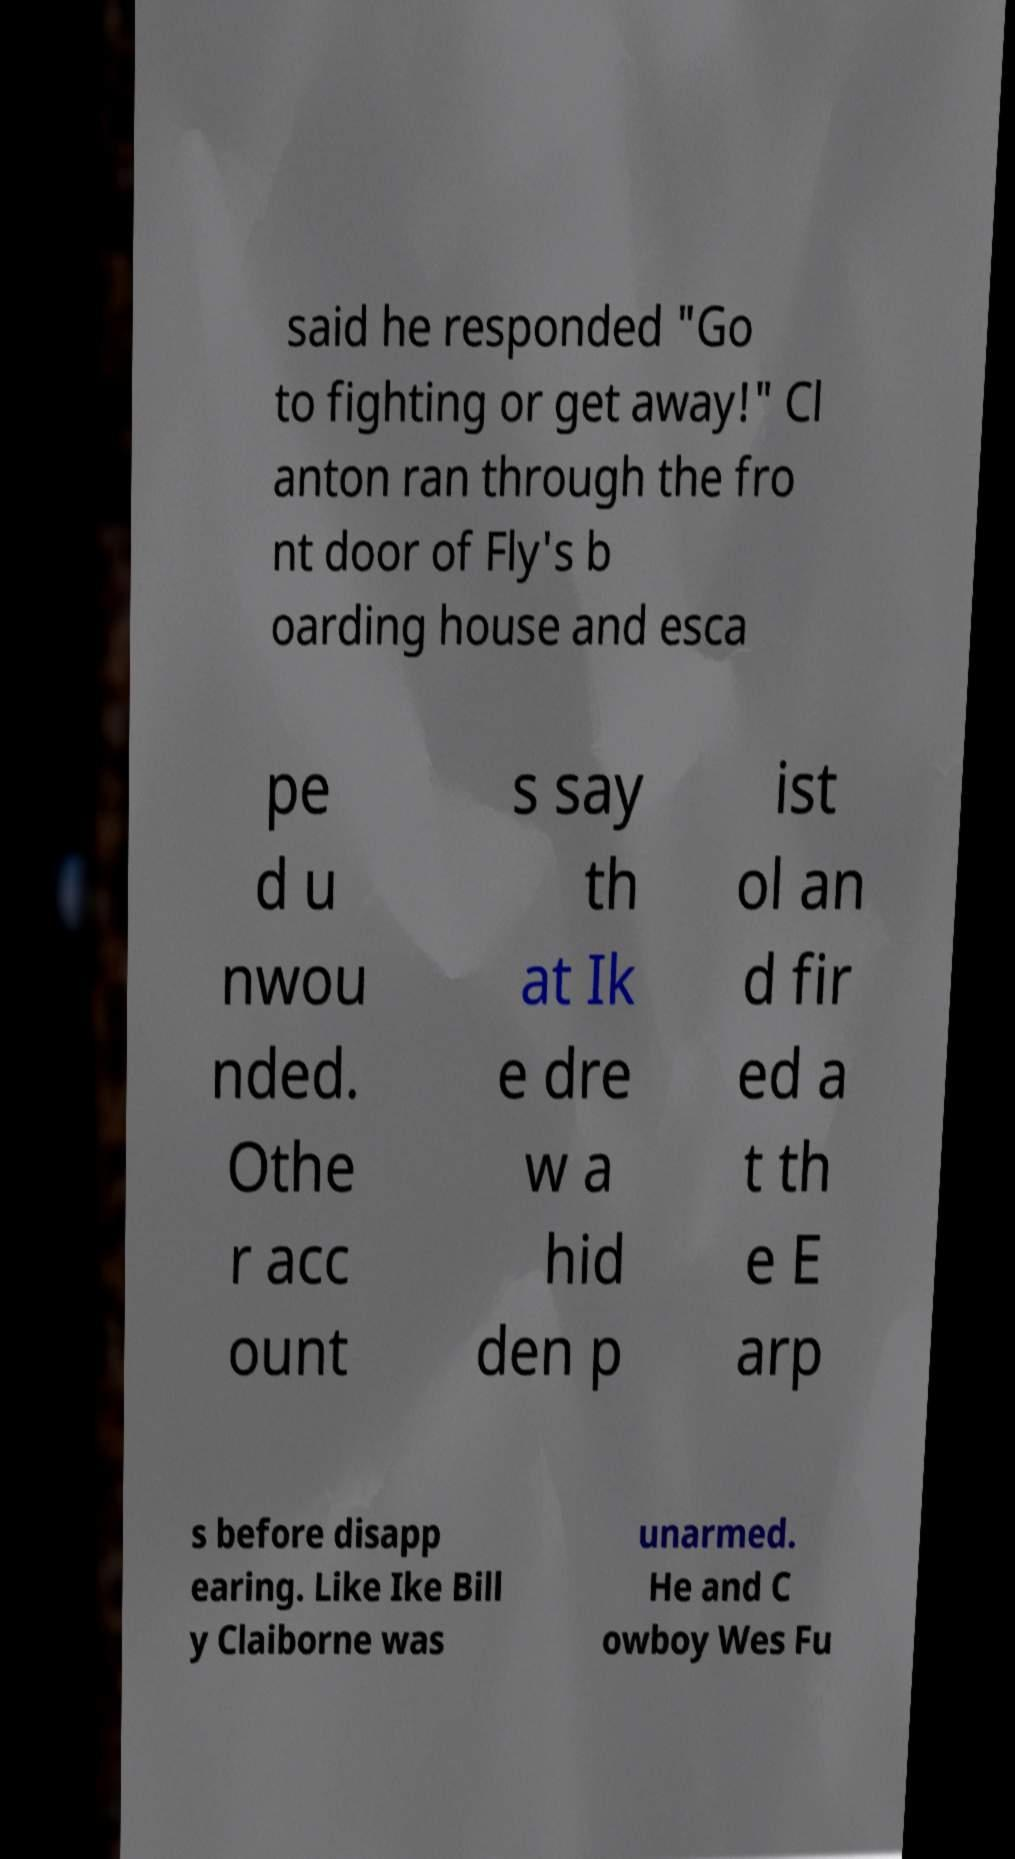There's text embedded in this image that I need extracted. Can you transcribe it verbatim? said he responded "Go to fighting or get away!" Cl anton ran through the fro nt door of Fly's b oarding house and esca pe d u nwou nded. Othe r acc ount s say th at Ik e dre w a hid den p ist ol an d fir ed a t th e E arp s before disapp earing. Like Ike Bill y Claiborne was unarmed. He and C owboy Wes Fu 